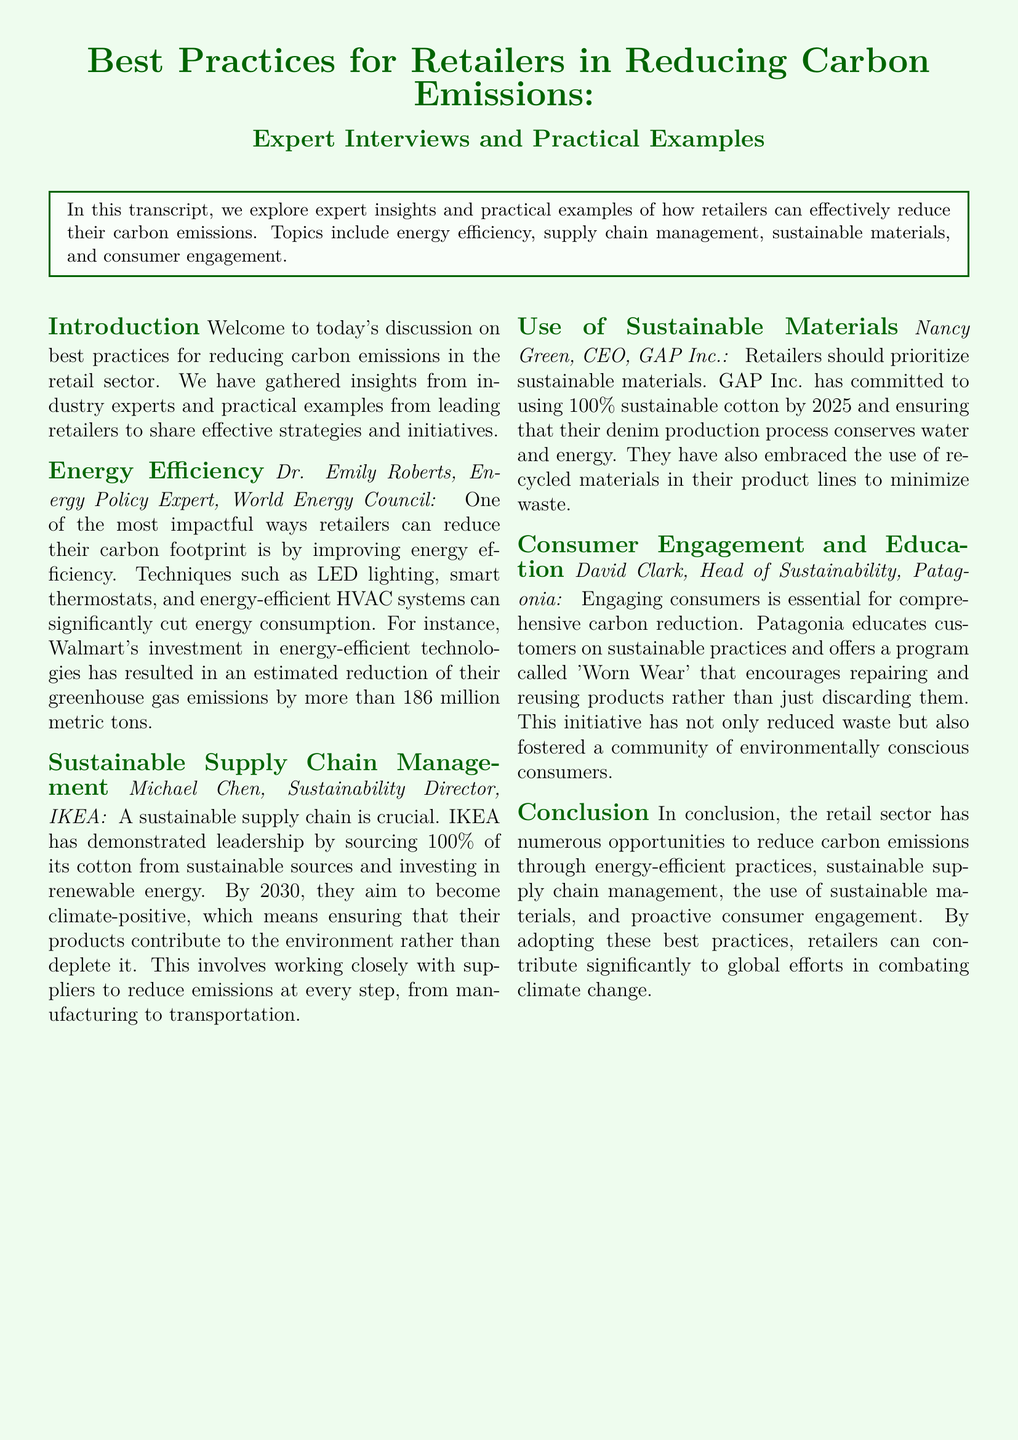What is one method retailers can use to reduce energy consumption? The document mentions techniques such as LED lighting, smart thermostats, and energy-efficient HVAC systems for reducing energy consumption.
Answer: LED lighting What is the target year for IKEA to become climate-positive? According to the document, IKEA aims to become climate-positive by 2030.
Answer: 2030 What percentage of sustainable cotton has GAP Inc. committed to using by 2025? The document states that GAP Inc. has committed to using 100% sustainable cotton by 2025.
Answer: 100% What initiative does Patagonia offer to encourage product reuse? The document describes Patagonia's 'Worn Wear' program that encourages repairing and reusing products.
Answer: Worn Wear How much greenhouse gas emissions has Walmart reportedly reduced through energy-efficient technologies? The transcript indicates that Walmart's investment in energy-efficient technologies has resulted in an estimated reduction of more than 186 million metric tons of greenhouse gas emissions.
Answer: 186 million metric tons Name one sustainable practice that IKEA has implemented in its supply chain. The document mentions that IKEA sources 100% of its cotton from sustainable sources as a sustainable practice.
Answer: Sourcing sustainable cotton What role does consumer education play according to Patagonia? The document explains that engaging consumers through education is essential for comprehensive carbon reduction.
Answer: Essential Who is the head of sustainability at Patagonia? The document specifies that David Clark is the Head of Sustainability at Patagonia.
Answer: David Clark 